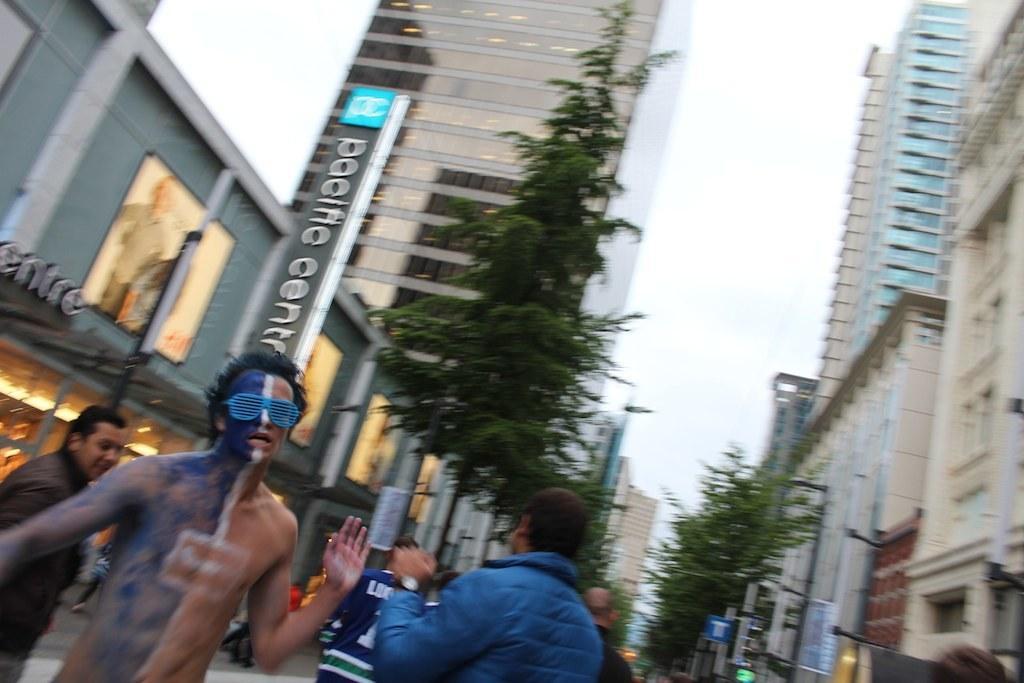In one or two sentences, can you explain what this image depicts? In this image I can see few persons. I can see a person wearing paint on his body. He is wearing spectacles. I can see few buildings. I can see few trees. I can see the sky. 